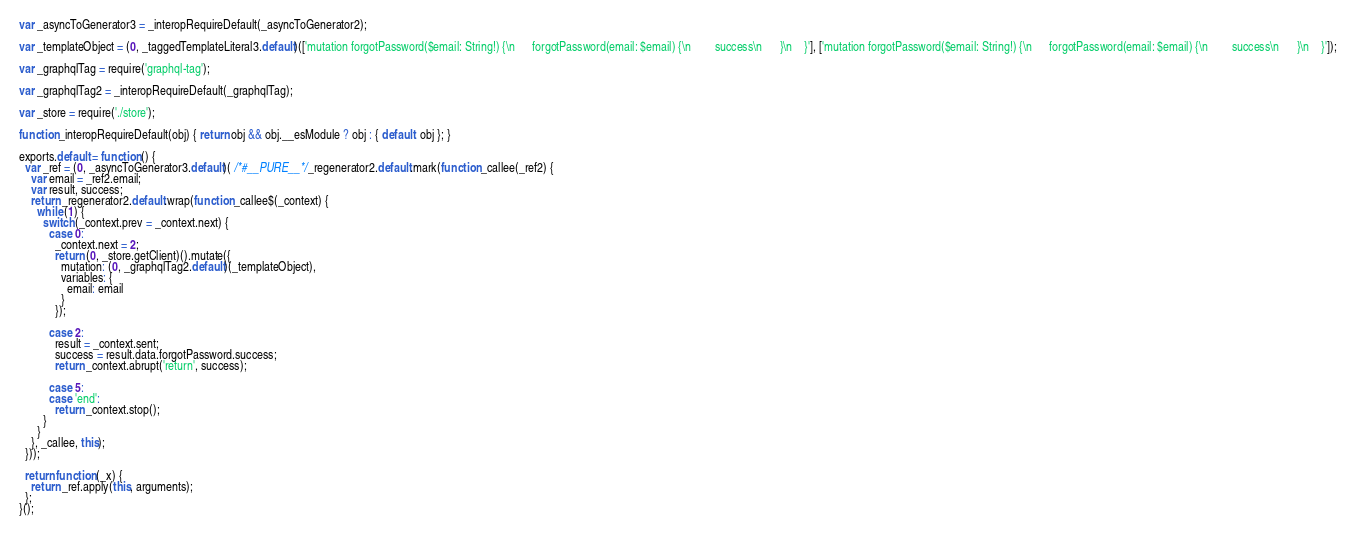Convert code to text. <code><loc_0><loc_0><loc_500><loc_500><_JavaScript_>
var _asyncToGenerator3 = _interopRequireDefault(_asyncToGenerator2);

var _templateObject = (0, _taggedTemplateLiteral3.default)(['mutation forgotPassword($email: String!) {\n      forgotPassword(email: $email) {\n        success\n      }\n    }'], ['mutation forgotPassword($email: String!) {\n      forgotPassword(email: $email) {\n        success\n      }\n    }']);

var _graphqlTag = require('graphql-tag');

var _graphqlTag2 = _interopRequireDefault(_graphqlTag);

var _store = require('./store');

function _interopRequireDefault(obj) { return obj && obj.__esModule ? obj : { default: obj }; }

exports.default = function () {
  var _ref = (0, _asyncToGenerator3.default)( /*#__PURE__*/_regenerator2.default.mark(function _callee(_ref2) {
    var email = _ref2.email;
    var result, success;
    return _regenerator2.default.wrap(function _callee$(_context) {
      while (1) {
        switch (_context.prev = _context.next) {
          case 0:
            _context.next = 2;
            return (0, _store.getClient)().mutate({
              mutation: (0, _graphqlTag2.default)(_templateObject),
              variables: {
                email: email
              }
            });

          case 2:
            result = _context.sent;
            success = result.data.forgotPassword.success;
            return _context.abrupt('return', success);

          case 5:
          case 'end':
            return _context.stop();
        }
      }
    }, _callee, this);
  }));

  return function (_x) {
    return _ref.apply(this, arguments);
  };
}();</code> 